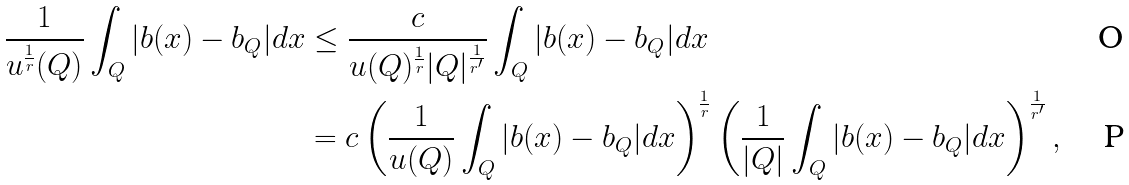Convert formula to latex. <formula><loc_0><loc_0><loc_500><loc_500>\frac { 1 } { u ^ { \frac { 1 } { r } } ( Q ) } \int _ { Q } | b ( x ) - b _ { Q } | d x & \leq \frac { c } { u ( Q ) ^ { \frac { 1 } { r } } | Q | ^ { \frac { 1 } { r ^ { \prime } } } } \int _ { Q } | b ( x ) - b _ { Q } | d x \\ & = c \left ( \frac { 1 } { u ( Q ) } \int _ { Q } | b ( x ) - b _ { Q } | d x \right ) ^ { \frac { 1 } { r } } \left ( \frac { 1 } { | Q | } \int _ { Q } | b ( x ) - b _ { Q } | d x \right ) ^ { \frac { 1 } { r ^ { \prime } } } ,</formula> 